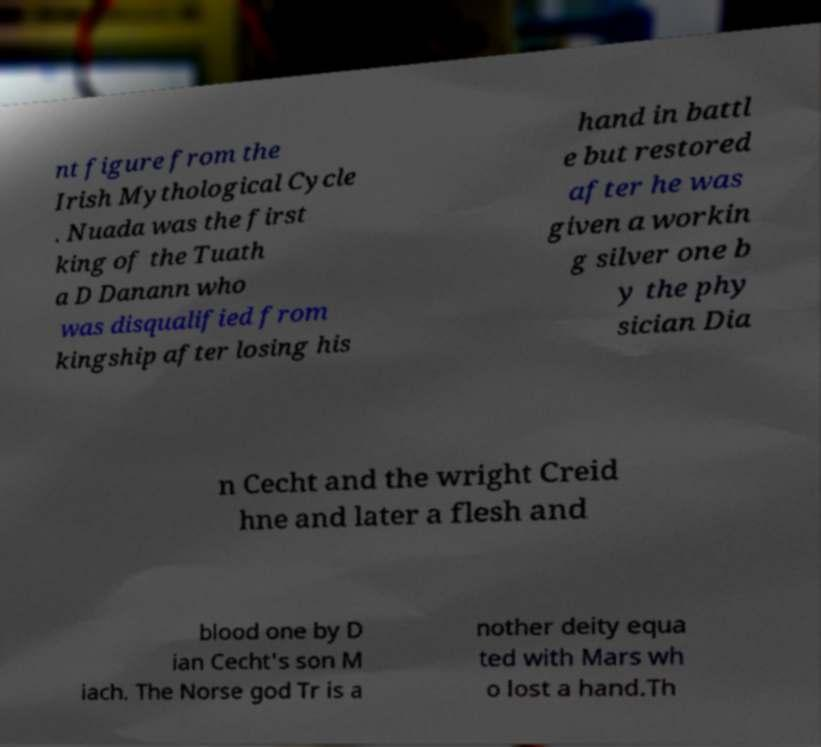Can you accurately transcribe the text from the provided image for me? nt figure from the Irish Mythological Cycle . Nuada was the first king of the Tuath a D Danann who was disqualified from kingship after losing his hand in battl e but restored after he was given a workin g silver one b y the phy sician Dia n Cecht and the wright Creid hne and later a flesh and blood one by D ian Cecht's son M iach. The Norse god Tr is a nother deity equa ted with Mars wh o lost a hand.Th 